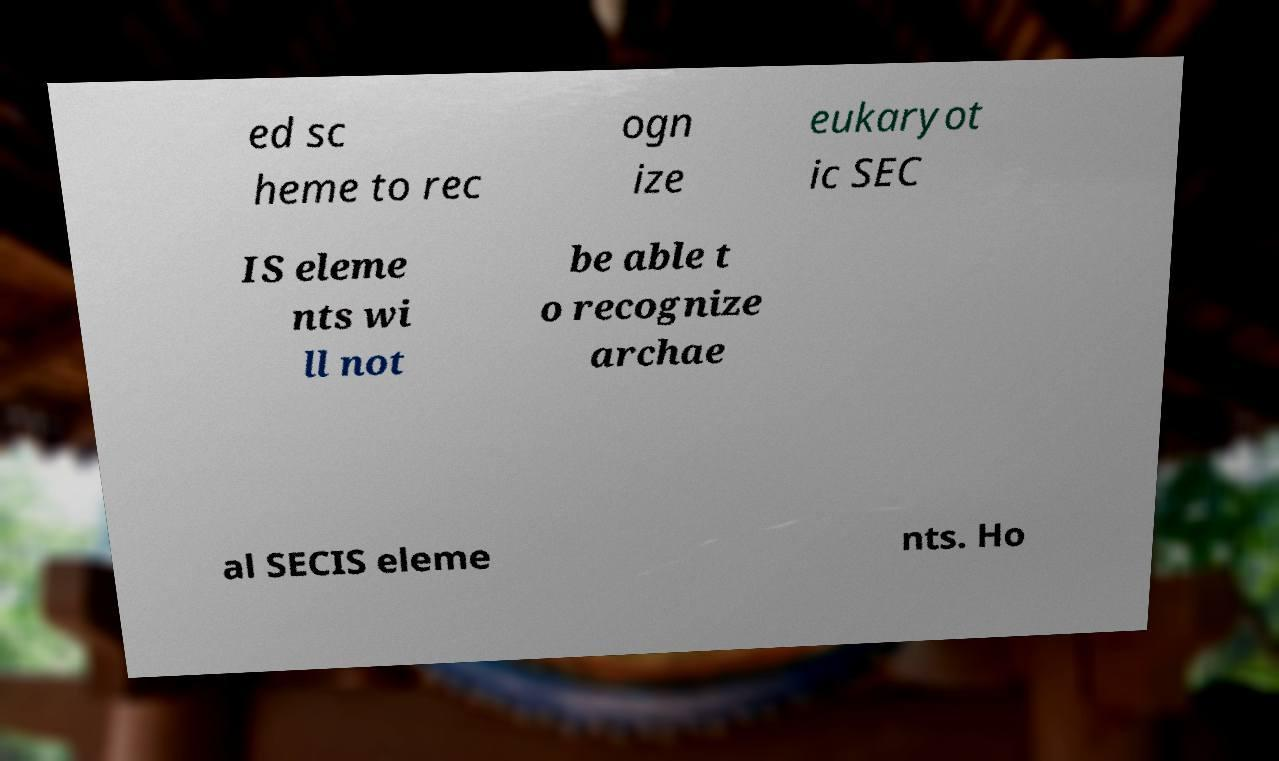Please identify and transcribe the text found in this image. ed sc heme to rec ogn ize eukaryot ic SEC IS eleme nts wi ll not be able t o recognize archae al SECIS eleme nts. Ho 